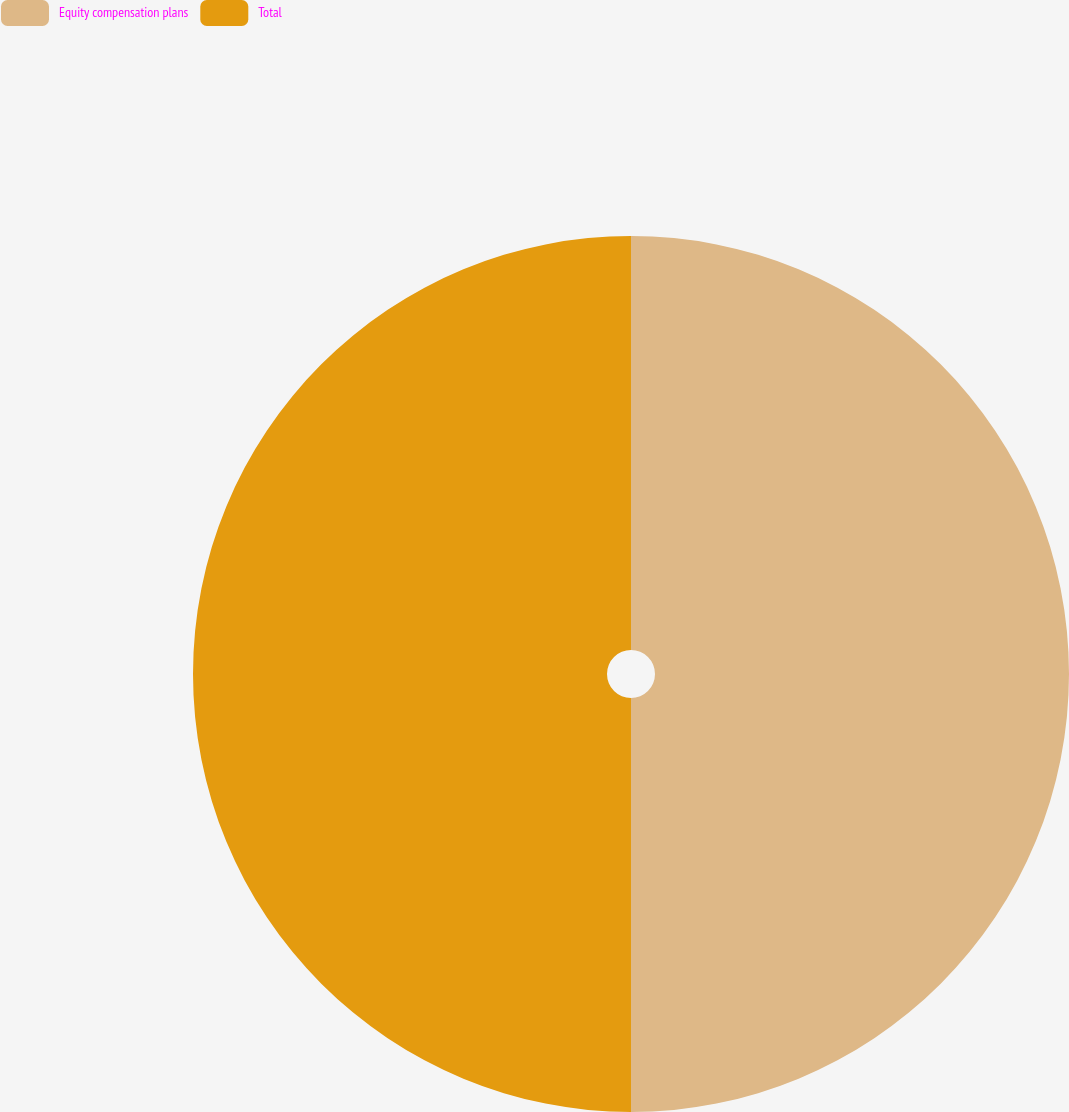Convert chart. <chart><loc_0><loc_0><loc_500><loc_500><pie_chart><fcel>Equity compensation plans<fcel>Total<nl><fcel>50.0%<fcel>50.0%<nl></chart> 